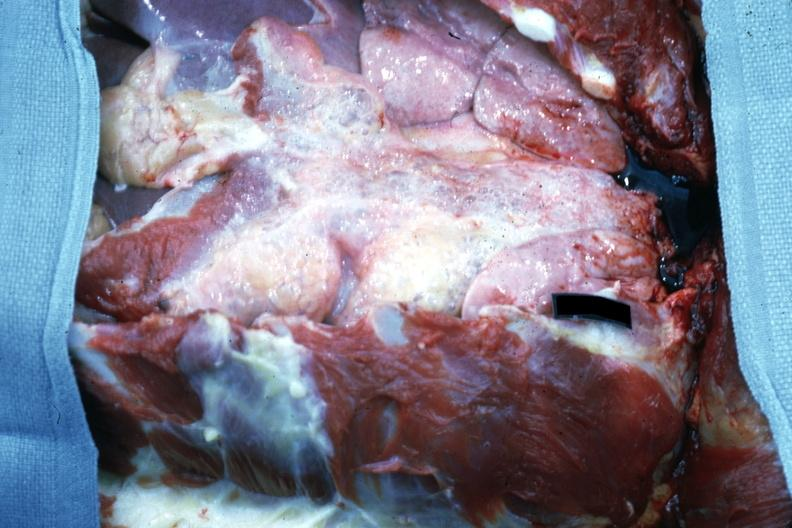does purulent sinusitis show opened chest with breast plate removed easily seen air bubbles?
Answer the question using a single word or phrase. No 